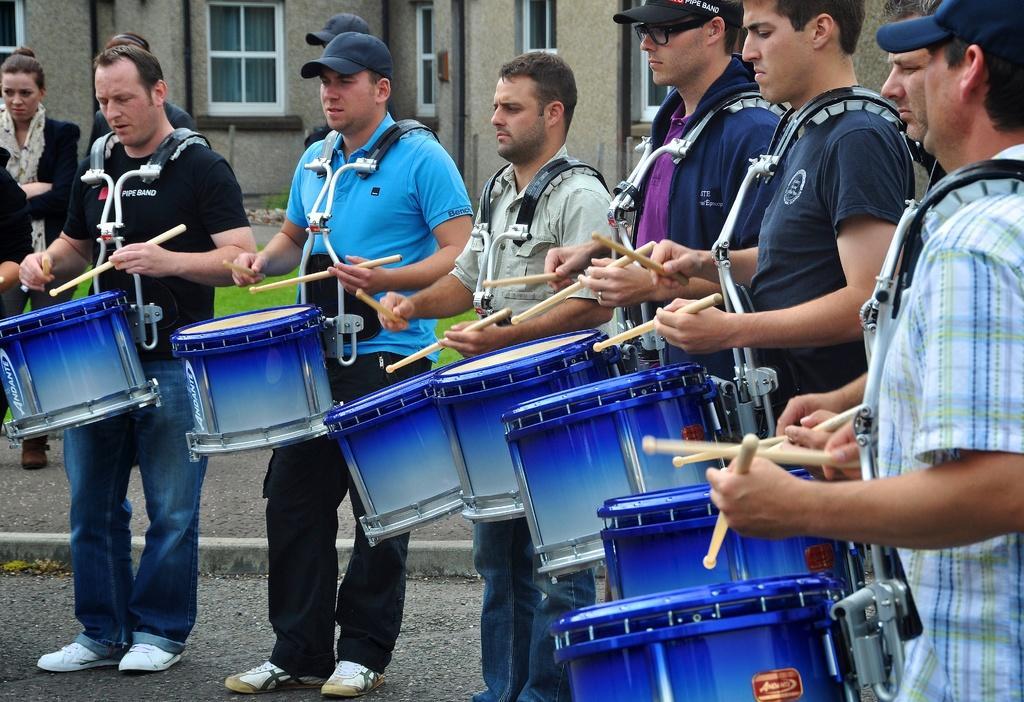How would you summarize this image in a sentence or two? In the center of the image, we can see people standing and playing drums and in the background, there is a building and at the bottom, there is road. 